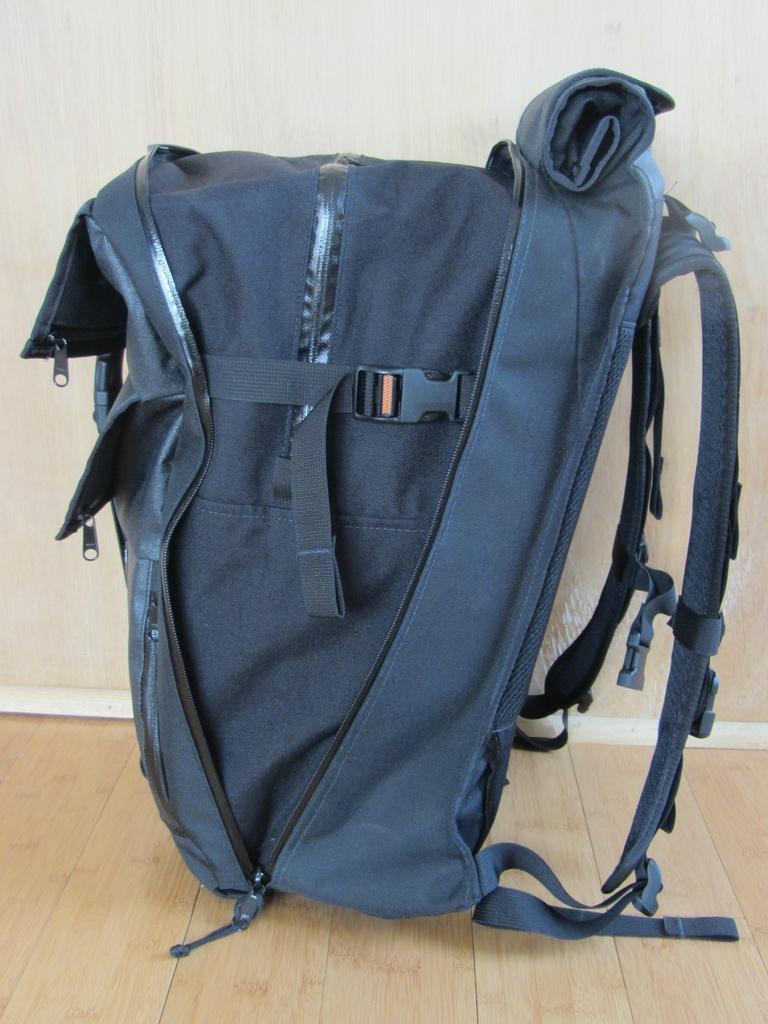Can you describe this image briefly? We can see blue color bag on the floor. On the background we can see wall. 